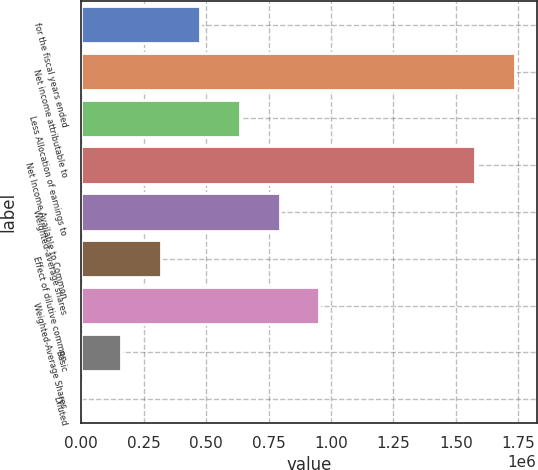Convert chart to OTSL. <chart><loc_0><loc_0><loc_500><loc_500><bar_chart><fcel>for the fiscal years ended<fcel>Net income attributable to<fcel>Less Allocation of earnings to<fcel>Net Income Available to Common<fcel>Weighted-average shares<fcel>Effect of dilutive common<fcel>Weighted-Average Shares<fcel>Basic<fcel>Diluted<nl><fcel>476469<fcel>1.73711e+06<fcel>635289<fcel>1.57829e+06<fcel>794110<fcel>317648<fcel>952930<fcel>158827<fcel>6.62<nl></chart> 